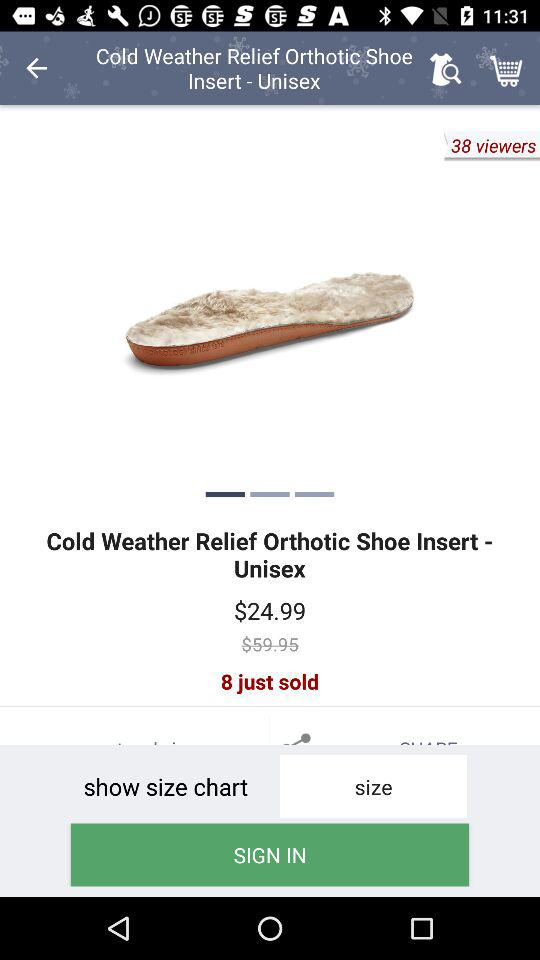What is the discounted price of the "Cold Weather Relief Orthotic Shoe Insert"? The discounted price is $24.99. 